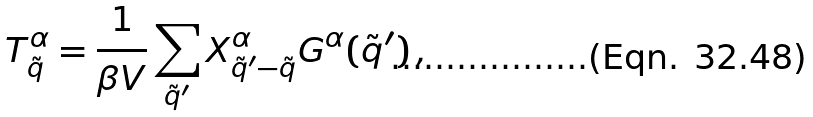<formula> <loc_0><loc_0><loc_500><loc_500>T ^ { \alpha } _ { \tilde { q } } = \frac { 1 } { \beta V } \sum _ { \tilde { q } ^ { \prime } } X ^ { \alpha } _ { \tilde { q } ^ { \prime } - \tilde { q } } G ^ { \alpha } ( \tilde { q } ^ { \prime } ) \, ,</formula> 